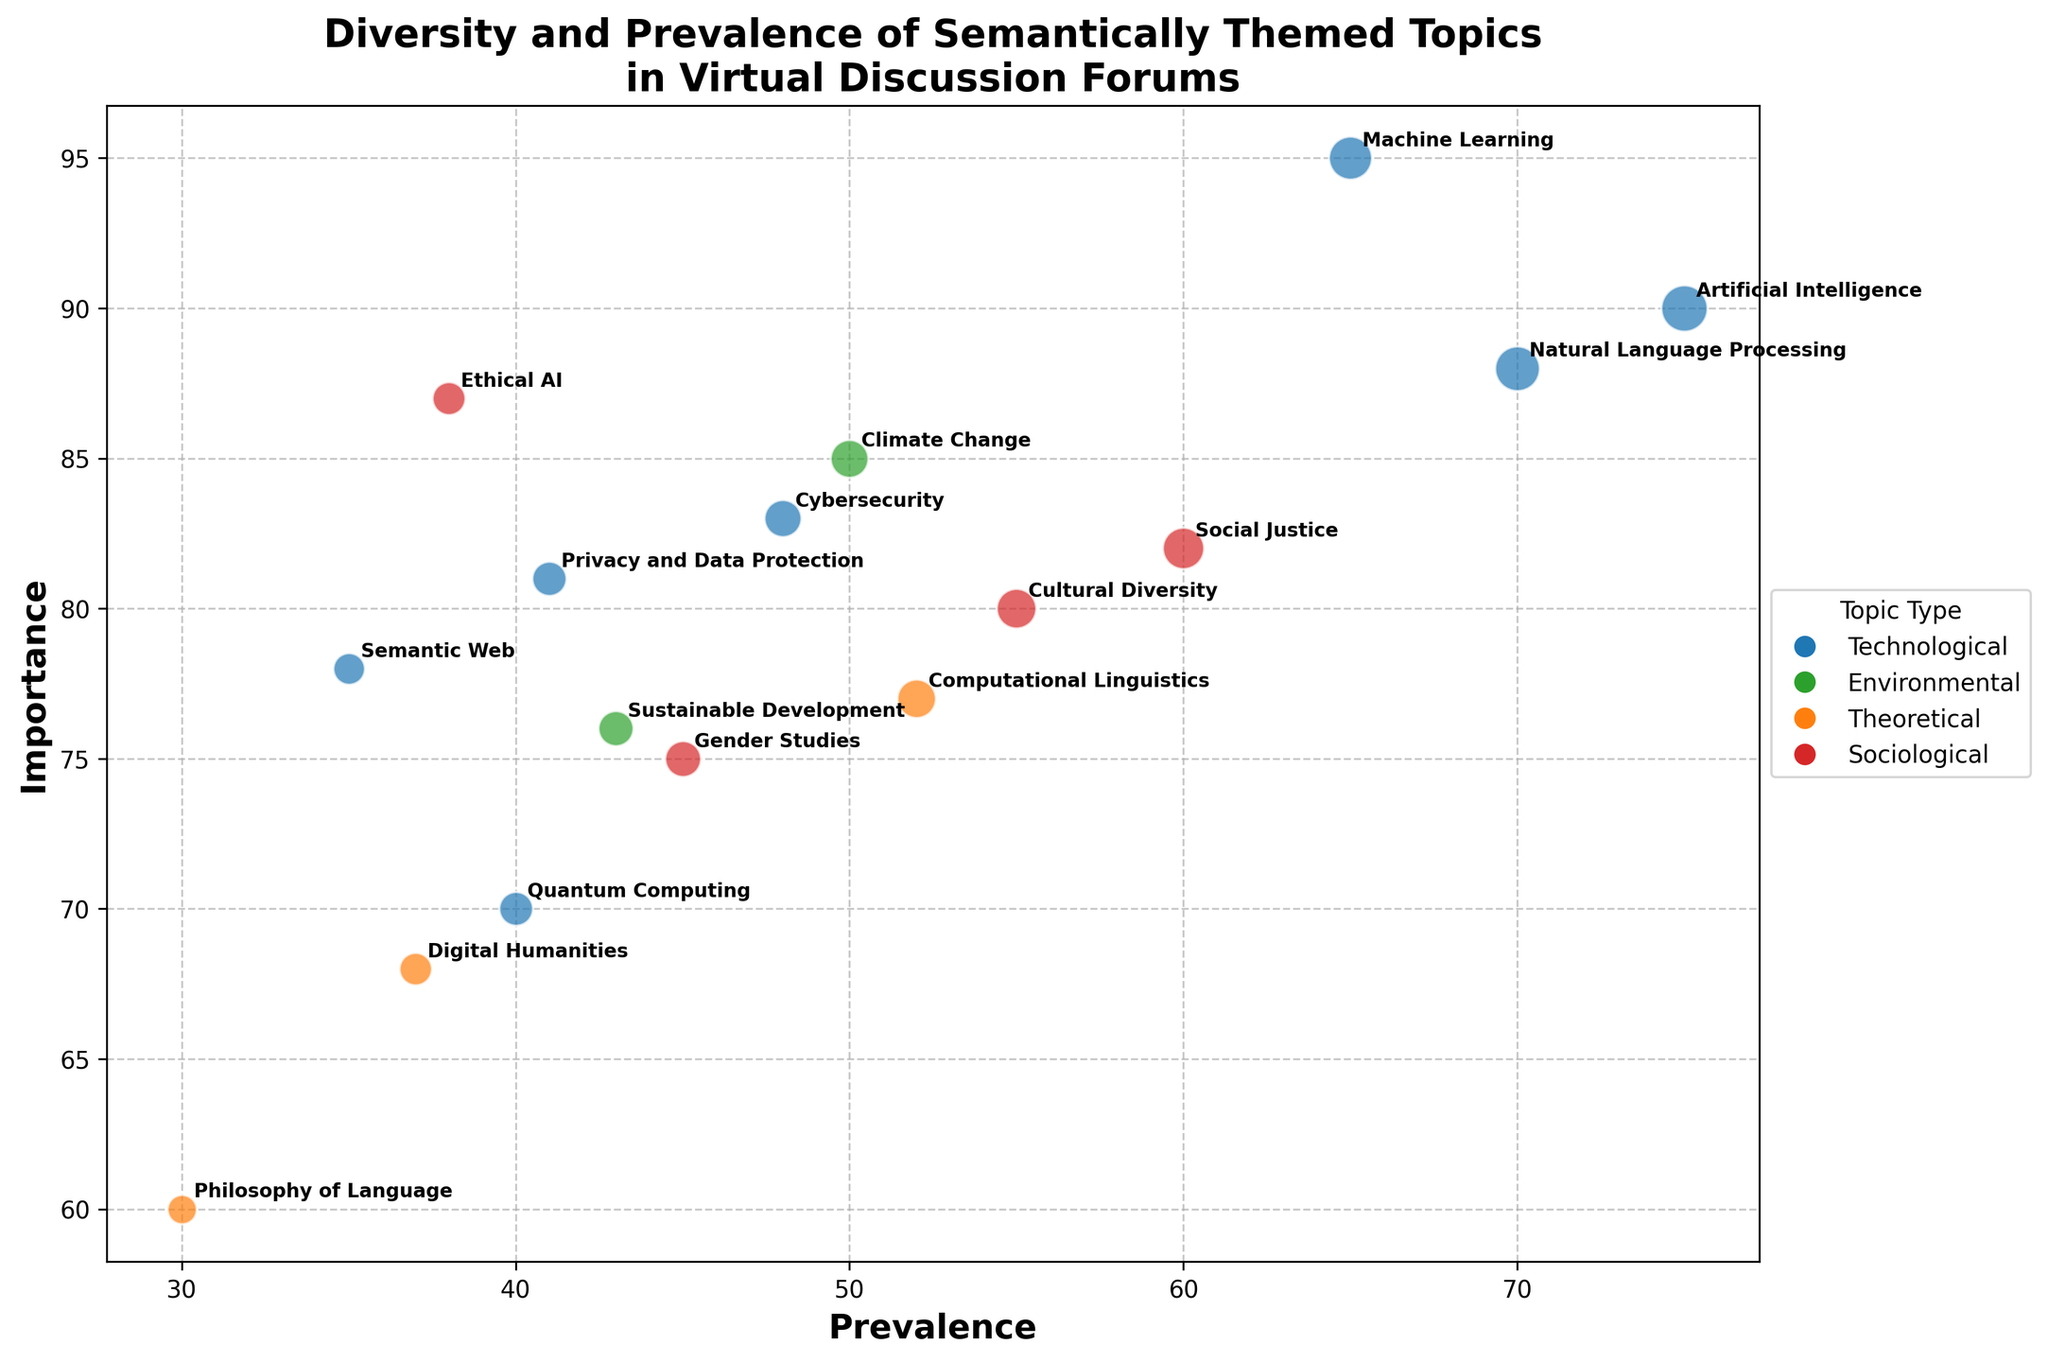What's the title of the figure? The title is usually located at the top of the figure and provides a summary of the chart's content. In this case, the title is "Diversity and Prevalence of Semantically Themed Topics in Virtual Discussion Forums."
Answer: Diversity and Prevalence of Semantically Themed Topics in Virtual Discussion Forums How many different types of topics are represented in the chart? The chart uses different colors to represent different types of topics. Each color in the legend corresponds to a topic type. In this chart, there are four distinct types of topics identified by colors.
Answer: Four Which topic has the highest prevalence? By examining the x-axis which represents prevalence, the bubble farthest to the right represents the topic with the highest prevalence. In this case, "Artificial Intelligence" is at 75, the farthest right position.
Answer: Artificial Intelligence What is the prevalence and importance of "Philosophy of Language"? Locate the bubble labeled "Philosophy of Language" and then look at its x (prevalence) and y (importance) coordinates. The prevalence is 30, and the importance is 60.
Answer: 30 and 60 Which topic is considered the most important? By checking the y-axis which represents importance, you can find the bubble that is the highest on the chart. "Machine Learning" has the highest importance at 95.
Answer: Machine Learning Compare the importance of "Climate Change" and "Gender Studies". Which one is considered more important? Locate the bubbles for "Climate Change" and "Gender Studies" and compare their y-coordinates, which correspond to importance. "Climate Change" has an importance of 85, and "Gender Studies" has an importance of 75.
Answer: Climate Change What is the average importance of Sociological topics depicted in the chart? Calculate the average by adding up the importance values of "Cultural Diversity" (80), "Gender Studies" (75), "Social Justice" (82), and "Ethical AI" (87), then divide by the number of topics (4). The sum is 324, and the average is 324/4.
Answer: 81 How many topics have a prevalence greater than 50? Count all the bubbles that have x-coordinates greater than 50. Based on the data provided: "Artificial Intelligence," "Machine Learning," "Natural Language Processing," "Cultural Diversity," "Social Justice". There are 5 topics.
Answer: Five Which type of topic has the most diverse occurrence (i.e., includes the highest and lowest prevalence values)? Compare the extremes of prevalence within each type. "Technological" topics range from "Quantum Computing" at 40 to "Artificial Intelligence" at 75, making it the type with the widest range.
Answer: Technological Is there any Technological topic that has lower importance than "Gender Studies"? Compare the importance values of Technological topics against "Gender Studies", which has an importance of 75. "Quantum Computing" (70) and "Digital Humanities" (68) are lower in importance.
Answer: Yes 